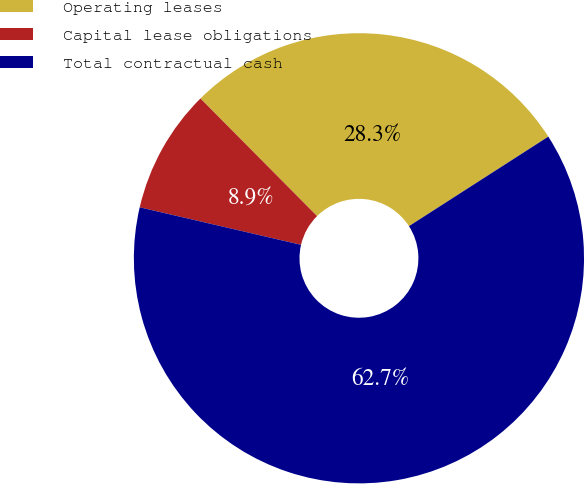Convert chart to OTSL. <chart><loc_0><loc_0><loc_500><loc_500><pie_chart><fcel>Operating leases<fcel>Capital lease obligations<fcel>Total contractual cash<nl><fcel>28.35%<fcel>8.93%<fcel>62.73%<nl></chart> 